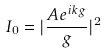<formula> <loc_0><loc_0><loc_500><loc_500>I _ { 0 } = | \frac { A e ^ { i k g } } { g } | ^ { 2 }</formula> 